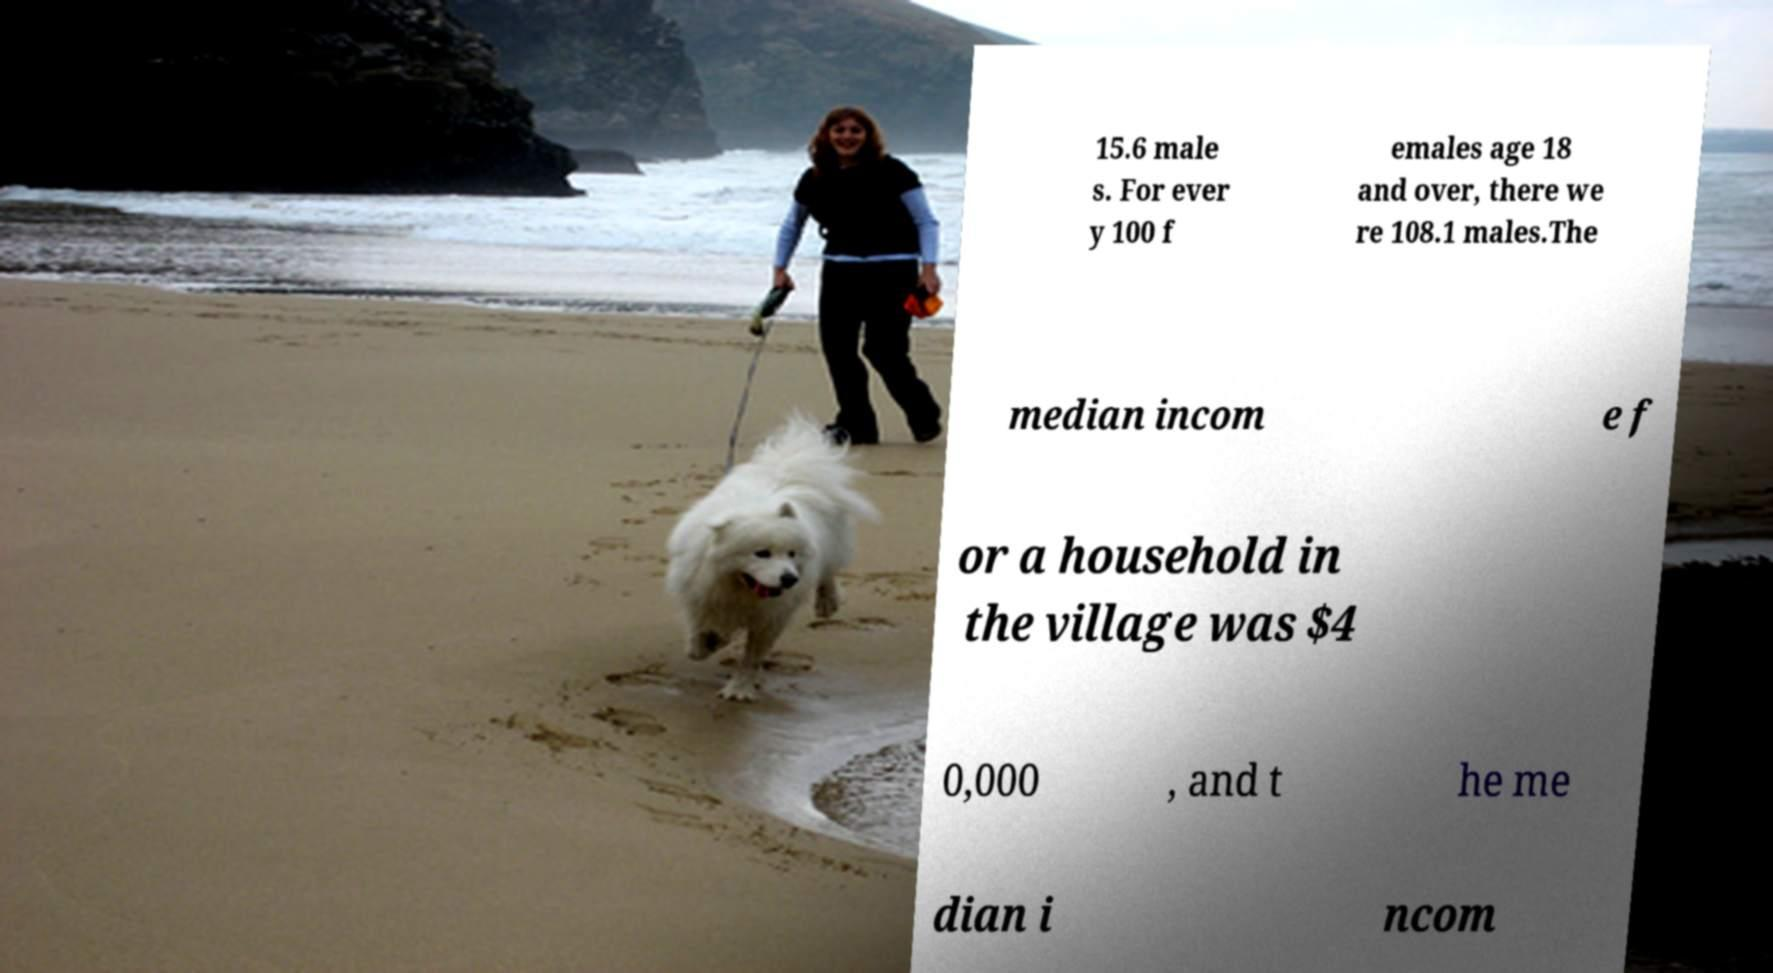I need the written content from this picture converted into text. Can you do that? 15.6 male s. For ever y 100 f emales age 18 and over, there we re 108.1 males.The median incom e f or a household in the village was $4 0,000 , and t he me dian i ncom 